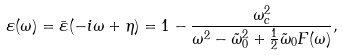<formula> <loc_0><loc_0><loc_500><loc_500>\varepsilon ( \omega ) = \bar { \varepsilon } ( - i \omega + \eta ) = 1 - \frac { \omega _ { c } ^ { 2 } } { \omega ^ { 2 } - \tilde { \omega } _ { 0 } ^ { 2 } + \frac { 1 } { 2 } \tilde { \omega } _ { 0 } F ( \omega ) } ,</formula> 